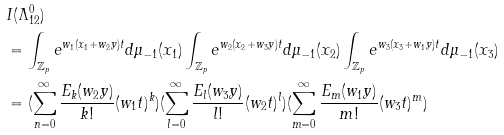Convert formula to latex. <formula><loc_0><loc_0><loc_500><loc_500>& I ( \Lambda _ { 1 2 } ^ { 0 } ) \\ & = \int _ { \mathbb { Z } _ { p } } e ^ { w _ { 1 } ( x _ { 1 } + w _ { 2 } y ) t } d \mu _ { - 1 } ( x _ { 1 } ) \int _ { \mathbb { Z } _ { p } } e ^ { w _ { 2 } ( x _ { 2 } + w _ { 3 } y ) t } d \mu _ { - 1 } ( x _ { 2 } ) \int _ { \mathbb { Z } _ { p } } e ^ { w _ { 3 } ( x _ { 3 } + w _ { 1 } y ) t } d \mu _ { - 1 } ( x _ { 3 } ) \\ & = ( \sum _ { n = 0 } ^ { \infty } \frac { E _ { k } ( w _ { 2 } y ) } { k ! } ( w _ { 1 } t ) ^ { k } ) ( \sum _ { l = 0 } ^ { \infty } \frac { E _ { l } ( w _ { 3 } y ) } { l ! } ( w _ { 2 } t ) ^ { l } ) ( \sum _ { m = 0 } ^ { \infty } \frac { E _ { m } ( w _ { 1 } y ) } { m ! } ( w _ { 3 } t ) ^ { m } )</formula> 